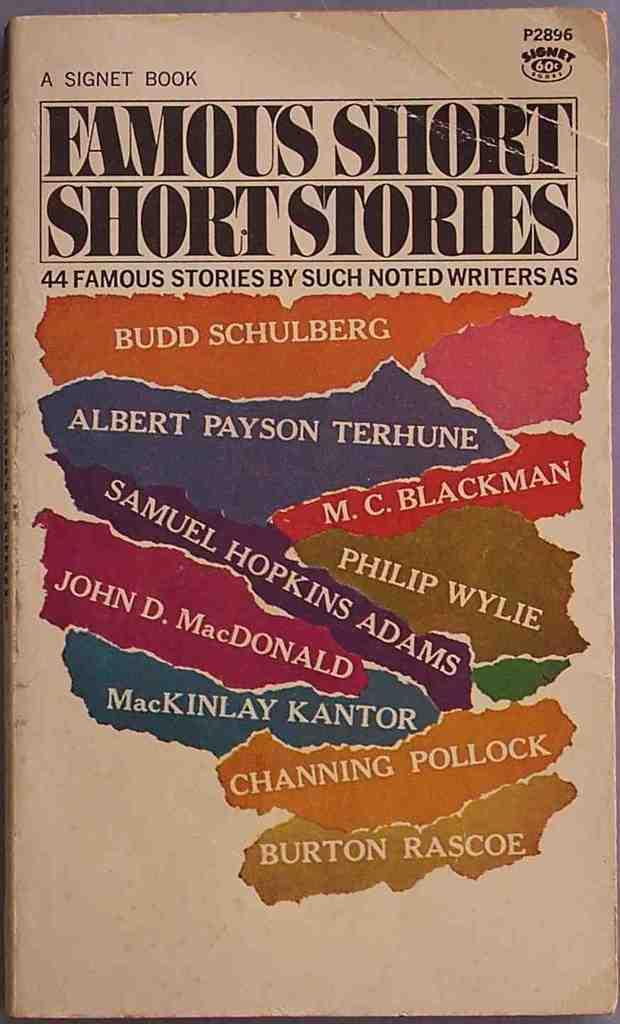<image>
Provide a brief description of the given image. A Signet book has famous shorty stories by many authors. 